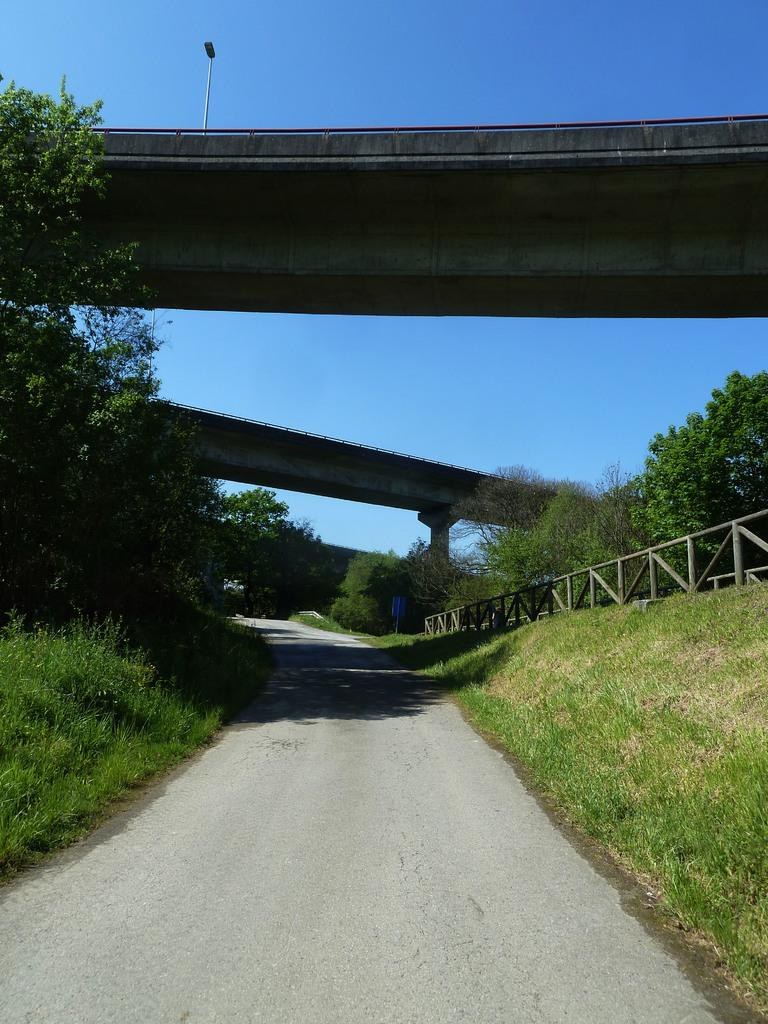What structures are located in the center of the image? There are two bridges in the center of the image. What can be seen on the right side of the image? There is a fence on the right side of the image. What type of vegetation is in the background of the image? There is a group of trees in the background of the image. What is visible in the background of the image besides the trees? The sky is visible in the background of the image. How does the fence spark in the image? There is no spark present in the image; the fence is stationary and not producing any sparks. What type of edge can be seen on the bridges in the image? The provided facts do not mention any specific edges on the bridges, so we cannot answer this question definitively. 